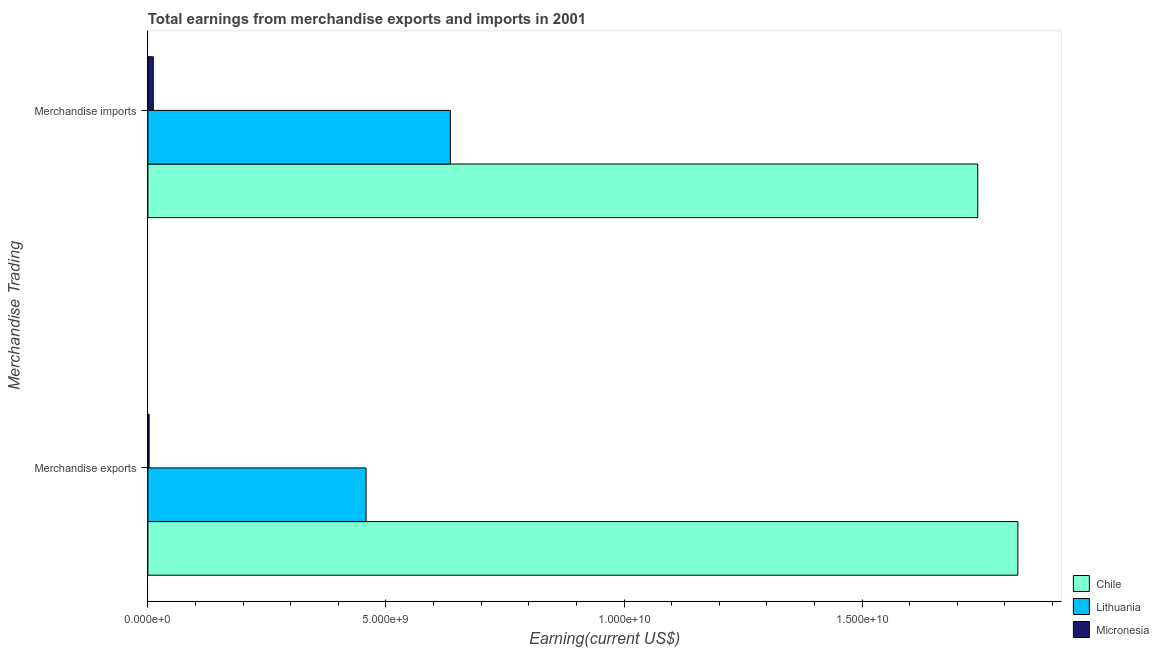How many different coloured bars are there?
Keep it short and to the point. 3. Are the number of bars per tick equal to the number of legend labels?
Provide a succinct answer. Yes. Are the number of bars on each tick of the Y-axis equal?
Keep it short and to the point. Yes. How many bars are there on the 2nd tick from the bottom?
Keep it short and to the point. 3. What is the earnings from merchandise exports in Chile?
Give a very brief answer. 1.83e+1. Across all countries, what is the maximum earnings from merchandise imports?
Offer a terse response. 1.74e+1. Across all countries, what is the minimum earnings from merchandise exports?
Your response must be concise. 2.65e+07. In which country was the earnings from merchandise imports minimum?
Provide a short and direct response. Micronesia. What is the total earnings from merchandise imports in the graph?
Offer a very short reply. 2.39e+1. What is the difference between the earnings from merchandise imports in Micronesia and that in Chile?
Your response must be concise. -1.73e+1. What is the difference between the earnings from merchandise exports in Lithuania and the earnings from merchandise imports in Chile?
Ensure brevity in your answer.  -1.28e+1. What is the average earnings from merchandise imports per country?
Provide a short and direct response. 7.97e+09. What is the difference between the earnings from merchandise exports and earnings from merchandise imports in Chile?
Offer a very short reply. 8.43e+08. In how many countries, is the earnings from merchandise exports greater than 15000000000 US$?
Provide a succinct answer. 1. What is the ratio of the earnings from merchandise exports in Lithuania to that in Micronesia?
Offer a terse response. 172.97. In how many countries, is the earnings from merchandise exports greater than the average earnings from merchandise exports taken over all countries?
Offer a terse response. 1. What does the 1st bar from the top in Merchandise imports represents?
Provide a short and direct response. Micronesia. What does the 3rd bar from the bottom in Merchandise exports represents?
Offer a terse response. Micronesia. Are all the bars in the graph horizontal?
Offer a very short reply. Yes. Does the graph contain grids?
Provide a succinct answer. No. Where does the legend appear in the graph?
Ensure brevity in your answer.  Bottom right. How many legend labels are there?
Ensure brevity in your answer.  3. How are the legend labels stacked?
Ensure brevity in your answer.  Vertical. What is the title of the graph?
Your answer should be compact. Total earnings from merchandise exports and imports in 2001. Does "Ireland" appear as one of the legend labels in the graph?
Make the answer very short. No. What is the label or title of the X-axis?
Ensure brevity in your answer.  Earning(current US$). What is the label or title of the Y-axis?
Your response must be concise. Merchandise Trading. What is the Earning(current US$) of Chile in Merchandise exports?
Keep it short and to the point. 1.83e+1. What is the Earning(current US$) of Lithuania in Merchandise exports?
Offer a terse response. 4.58e+09. What is the Earning(current US$) in Micronesia in Merchandise exports?
Make the answer very short. 2.65e+07. What is the Earning(current US$) in Chile in Merchandise imports?
Your response must be concise. 1.74e+1. What is the Earning(current US$) of Lithuania in Merchandise imports?
Provide a short and direct response. 6.35e+09. What is the Earning(current US$) of Micronesia in Merchandise imports?
Make the answer very short. 1.14e+08. Across all Merchandise Trading, what is the maximum Earning(current US$) in Chile?
Your answer should be compact. 1.83e+1. Across all Merchandise Trading, what is the maximum Earning(current US$) in Lithuania?
Provide a succinct answer. 6.35e+09. Across all Merchandise Trading, what is the maximum Earning(current US$) of Micronesia?
Keep it short and to the point. 1.14e+08. Across all Merchandise Trading, what is the minimum Earning(current US$) in Chile?
Ensure brevity in your answer.  1.74e+1. Across all Merchandise Trading, what is the minimum Earning(current US$) in Lithuania?
Give a very brief answer. 4.58e+09. Across all Merchandise Trading, what is the minimum Earning(current US$) in Micronesia?
Offer a terse response. 2.65e+07. What is the total Earning(current US$) in Chile in the graph?
Offer a terse response. 3.57e+1. What is the total Earning(current US$) in Lithuania in the graph?
Offer a very short reply. 1.09e+1. What is the total Earning(current US$) in Micronesia in the graph?
Offer a terse response. 1.40e+08. What is the difference between the Earning(current US$) in Chile in Merchandise exports and that in Merchandise imports?
Your answer should be very brief. 8.43e+08. What is the difference between the Earning(current US$) of Lithuania in Merchandise exports and that in Merchandise imports?
Ensure brevity in your answer.  -1.77e+09. What is the difference between the Earning(current US$) in Micronesia in Merchandise exports and that in Merchandise imports?
Provide a succinct answer. -8.73e+07. What is the difference between the Earning(current US$) of Chile in Merchandise exports and the Earning(current US$) of Lithuania in Merchandise imports?
Provide a short and direct response. 1.19e+1. What is the difference between the Earning(current US$) of Chile in Merchandise exports and the Earning(current US$) of Micronesia in Merchandise imports?
Give a very brief answer. 1.82e+1. What is the difference between the Earning(current US$) of Lithuania in Merchandise exports and the Earning(current US$) of Micronesia in Merchandise imports?
Ensure brevity in your answer.  4.47e+09. What is the average Earning(current US$) in Chile per Merchandise Trading?
Your answer should be very brief. 1.79e+1. What is the average Earning(current US$) in Lithuania per Merchandise Trading?
Offer a terse response. 5.47e+09. What is the average Earning(current US$) of Micronesia per Merchandise Trading?
Make the answer very short. 7.02e+07. What is the difference between the Earning(current US$) of Chile and Earning(current US$) of Lithuania in Merchandise exports?
Give a very brief answer. 1.37e+1. What is the difference between the Earning(current US$) of Chile and Earning(current US$) of Micronesia in Merchandise exports?
Give a very brief answer. 1.82e+1. What is the difference between the Earning(current US$) in Lithuania and Earning(current US$) in Micronesia in Merchandise exports?
Your answer should be very brief. 4.56e+09. What is the difference between the Earning(current US$) of Chile and Earning(current US$) of Lithuania in Merchandise imports?
Keep it short and to the point. 1.11e+1. What is the difference between the Earning(current US$) of Chile and Earning(current US$) of Micronesia in Merchandise imports?
Give a very brief answer. 1.73e+1. What is the difference between the Earning(current US$) in Lithuania and Earning(current US$) in Micronesia in Merchandise imports?
Your response must be concise. 6.24e+09. What is the ratio of the Earning(current US$) in Chile in Merchandise exports to that in Merchandise imports?
Offer a very short reply. 1.05. What is the ratio of the Earning(current US$) of Lithuania in Merchandise exports to that in Merchandise imports?
Provide a short and direct response. 0.72. What is the ratio of the Earning(current US$) of Micronesia in Merchandise exports to that in Merchandise imports?
Keep it short and to the point. 0.23. What is the difference between the highest and the second highest Earning(current US$) in Chile?
Give a very brief answer. 8.43e+08. What is the difference between the highest and the second highest Earning(current US$) in Lithuania?
Your answer should be compact. 1.77e+09. What is the difference between the highest and the second highest Earning(current US$) of Micronesia?
Provide a succinct answer. 8.73e+07. What is the difference between the highest and the lowest Earning(current US$) of Chile?
Provide a succinct answer. 8.43e+08. What is the difference between the highest and the lowest Earning(current US$) in Lithuania?
Make the answer very short. 1.77e+09. What is the difference between the highest and the lowest Earning(current US$) of Micronesia?
Offer a terse response. 8.73e+07. 